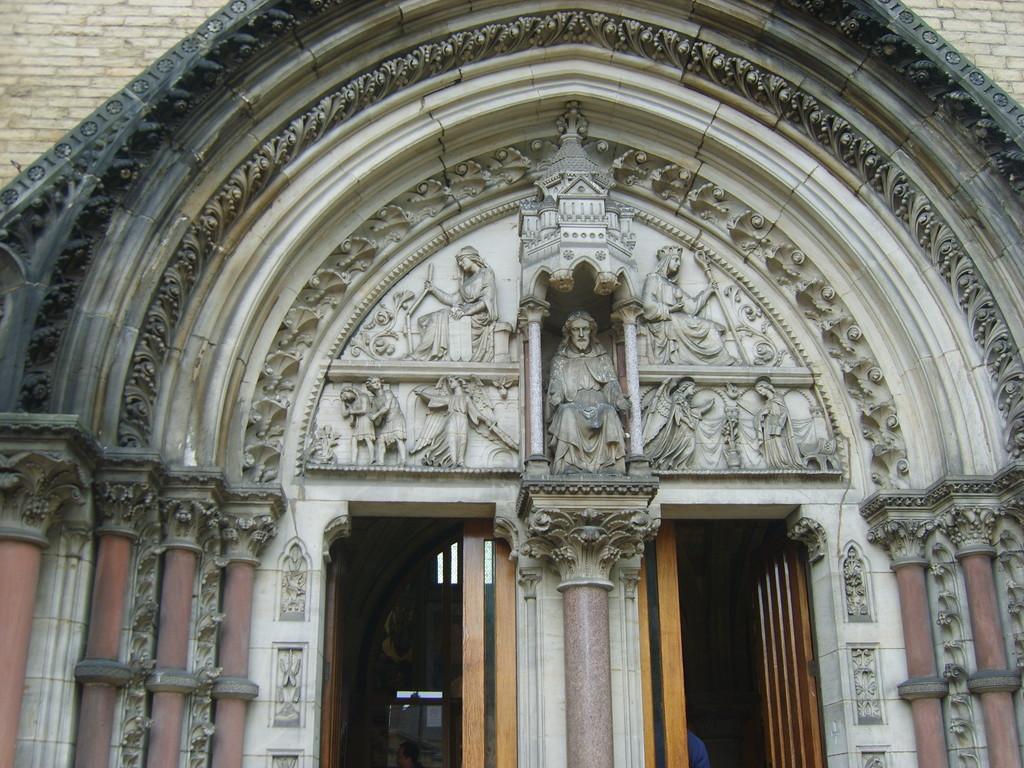Describe this image in one or two sentences. There is a building with doors and pillars. On the building there are some sculptures. 